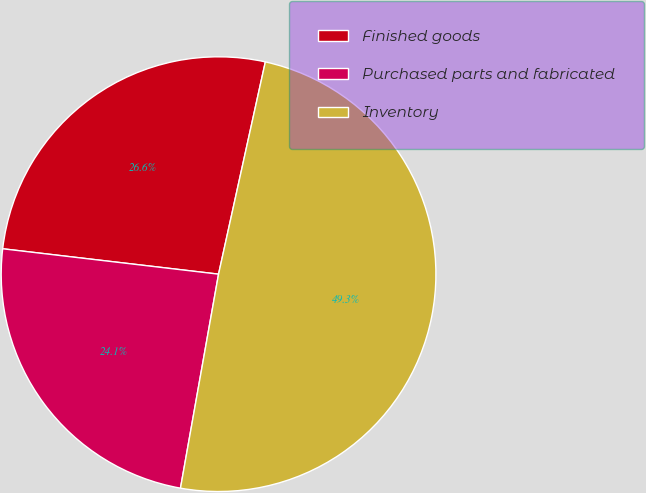Convert chart to OTSL. <chart><loc_0><loc_0><loc_500><loc_500><pie_chart><fcel>Finished goods<fcel>Purchased parts and fabricated<fcel>Inventory<nl><fcel>26.59%<fcel>24.06%<fcel>49.35%<nl></chart> 